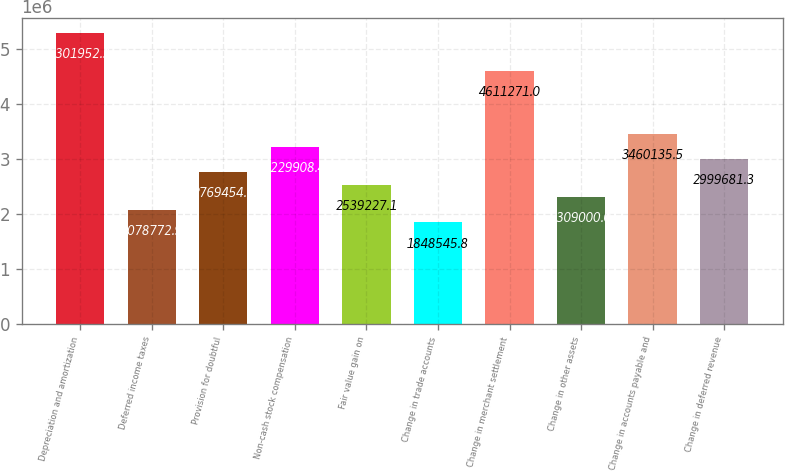Convert chart. <chart><loc_0><loc_0><loc_500><loc_500><bar_chart><fcel>Depreciation and amortization<fcel>Deferred income taxes<fcel>Provision for doubtful<fcel>Non-cash stock compensation<fcel>Fair value gain on<fcel>Change in trade accounts<fcel>Change in merchant settlement<fcel>Change in other assets<fcel>Change in accounts payable and<fcel>Change in deferred revenue<nl><fcel>5.30195e+06<fcel>2.07877e+06<fcel>2.76945e+06<fcel>3.22991e+06<fcel>2.53923e+06<fcel>1.84855e+06<fcel>4.61127e+06<fcel>2.309e+06<fcel>3.46014e+06<fcel>2.99968e+06<nl></chart> 